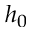Convert formula to latex. <formula><loc_0><loc_0><loc_500><loc_500>h _ { 0 }</formula> 